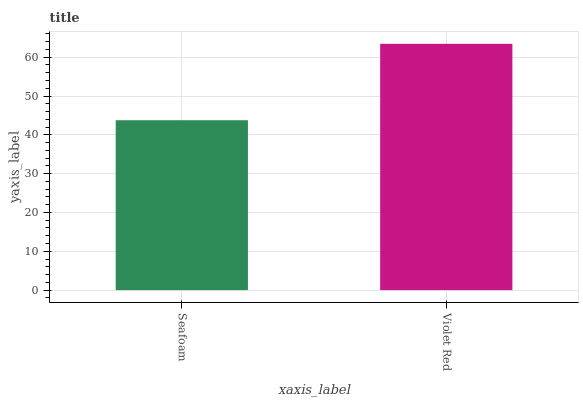Is Seafoam the minimum?
Answer yes or no. Yes. Is Violet Red the maximum?
Answer yes or no. Yes. Is Violet Red the minimum?
Answer yes or no. No. Is Violet Red greater than Seafoam?
Answer yes or no. Yes. Is Seafoam less than Violet Red?
Answer yes or no. Yes. Is Seafoam greater than Violet Red?
Answer yes or no. No. Is Violet Red less than Seafoam?
Answer yes or no. No. Is Violet Red the high median?
Answer yes or no. Yes. Is Seafoam the low median?
Answer yes or no. Yes. Is Seafoam the high median?
Answer yes or no. No. Is Violet Red the low median?
Answer yes or no. No. 